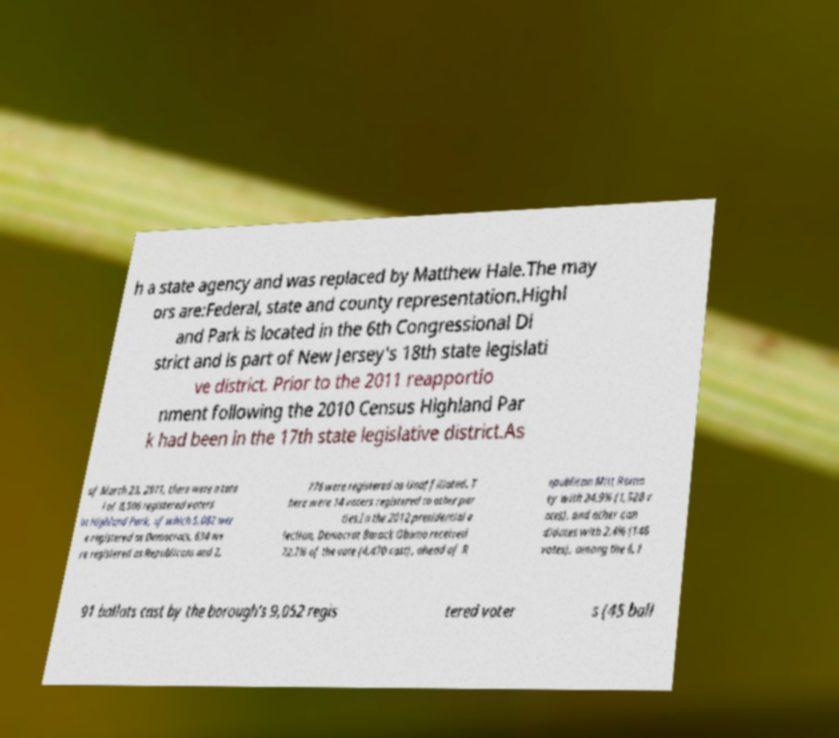Can you read and provide the text displayed in the image?This photo seems to have some interesting text. Can you extract and type it out for me? h a state agency and was replaced by Matthew Hale.The may ors are:Federal, state and county representation.Highl and Park is located in the 6th Congressional Di strict and is part of New Jersey's 18th state legislati ve district. Prior to the 2011 reapportio nment following the 2010 Census Highland Par k had been in the 17th state legislative district.As of March 23, 2011, there were a tota l of 8,506 registered voters in Highland Park, of which 5,082 wer e registered as Democrats, 634 we re registered as Republicans and 2, 776 were registered as Unaffiliated. T here were 14 voters registered to other par ties.In the 2012 presidential e lection, Democrat Barack Obama received 72.7% of the vote (4,470 cast), ahead of R epublican Mitt Romn ey with 24.9% (1,528 v otes), and other can didates with 2.4% (148 votes), among the 6,1 91 ballots cast by the borough's 9,052 regis tered voter s (45 ball 